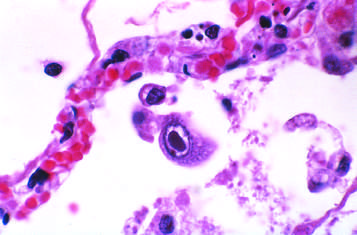what show distinct nuclear inclusions?
Answer the question using a single word or phrase. Infected cells 